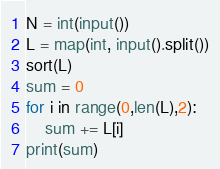<code> <loc_0><loc_0><loc_500><loc_500><_Python_>N = int(input())
L = map(int, input().split())
sort(L)
sum = 0
for i in range(0,len(L),2):
	sum += L[i]
print(sum)</code> 